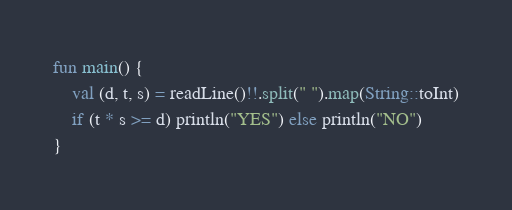<code> <loc_0><loc_0><loc_500><loc_500><_Kotlin_>fun main() {
    val (d, t, s) = readLine()!!.split(" ").map(String::toInt)
    if (t * s >= d) println("YES") else println("NO")
}</code> 